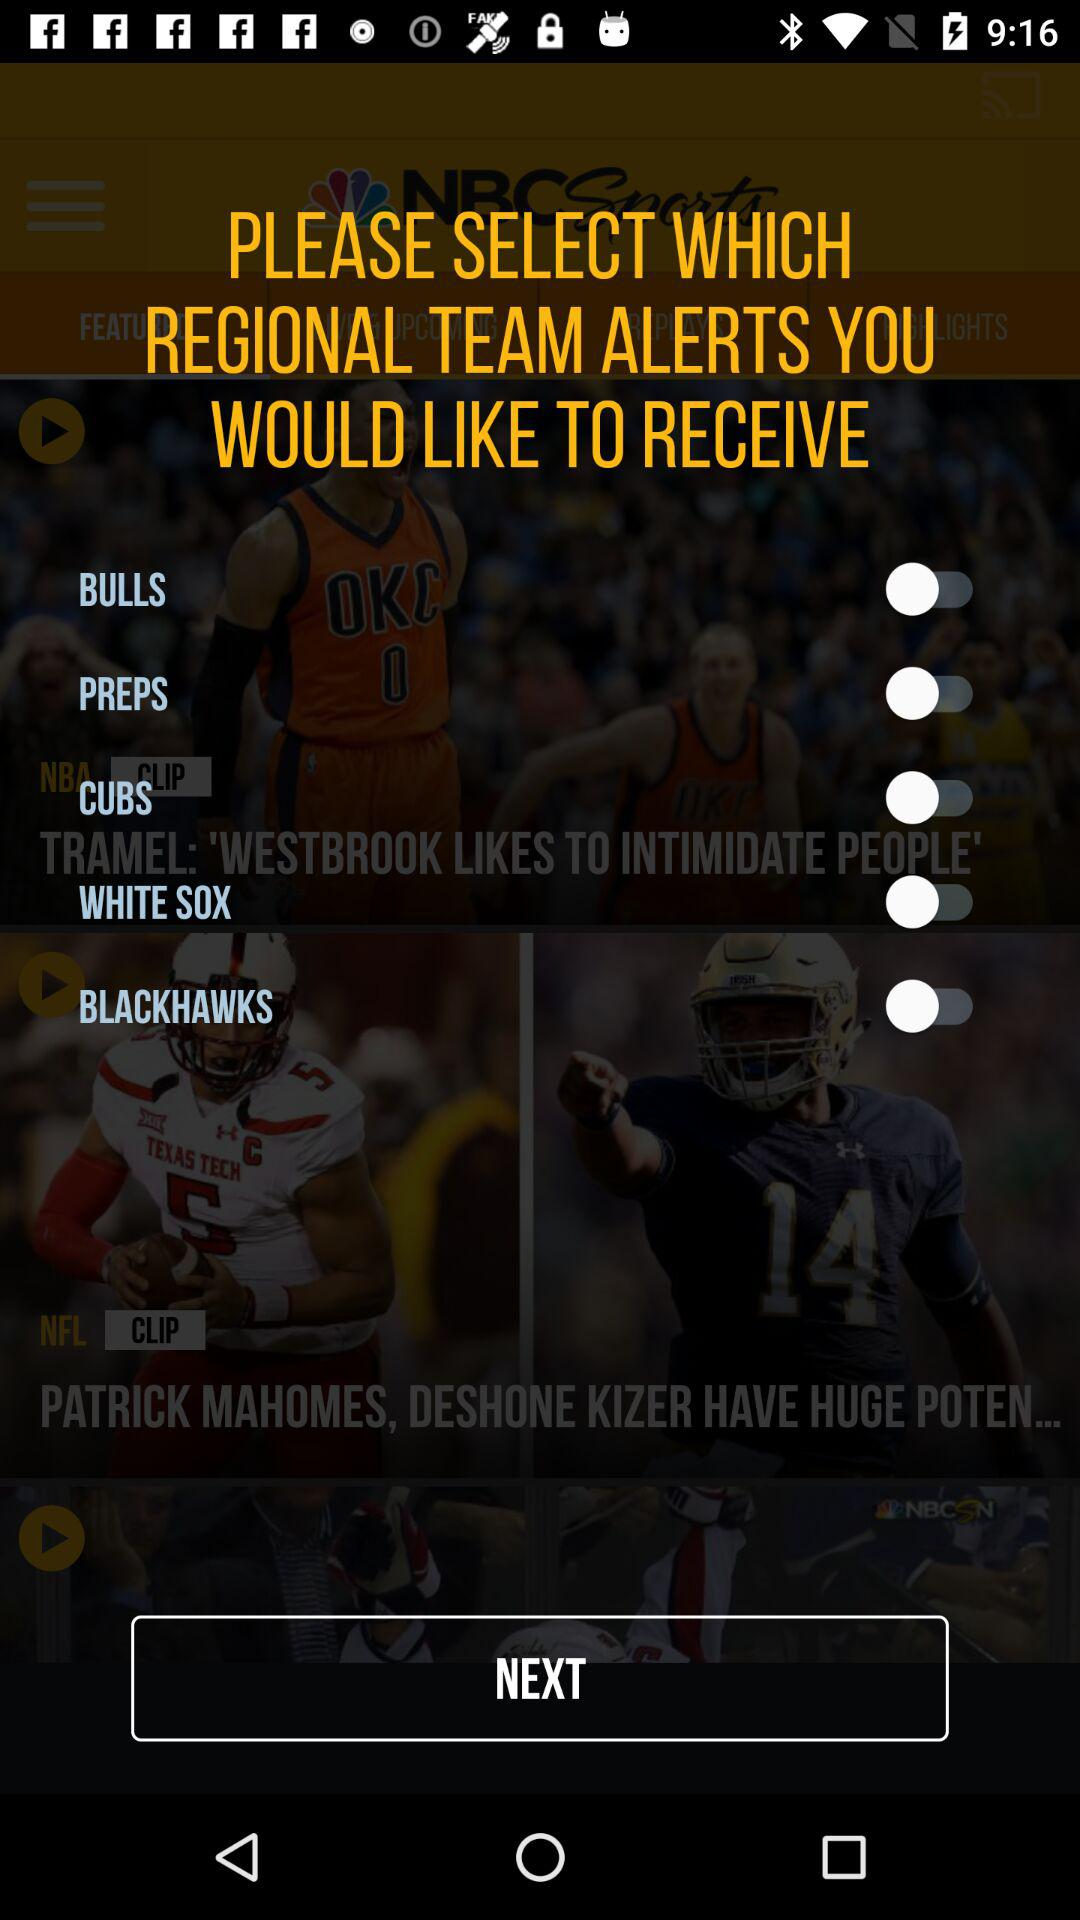What are the names of the regional teams? The names of the regional teams are "BULLS", "PREPS", "CUBS", "WHITE SOX" and "BLACKHAWKS". 